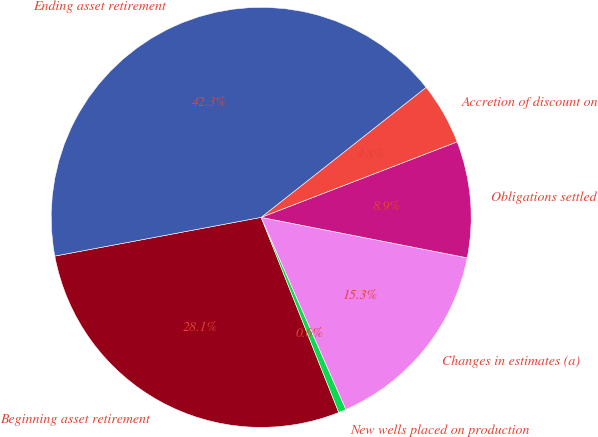Convert chart to OTSL. <chart><loc_0><loc_0><loc_500><loc_500><pie_chart><fcel>Beginning asset retirement<fcel>New wells placed on production<fcel>Changes in estimates (a)<fcel>Obligations settled<fcel>Accretion of discount on<fcel>Ending asset retirement<nl><fcel>28.07%<fcel>0.59%<fcel>15.3%<fcel>8.94%<fcel>4.77%<fcel>42.33%<nl></chart> 